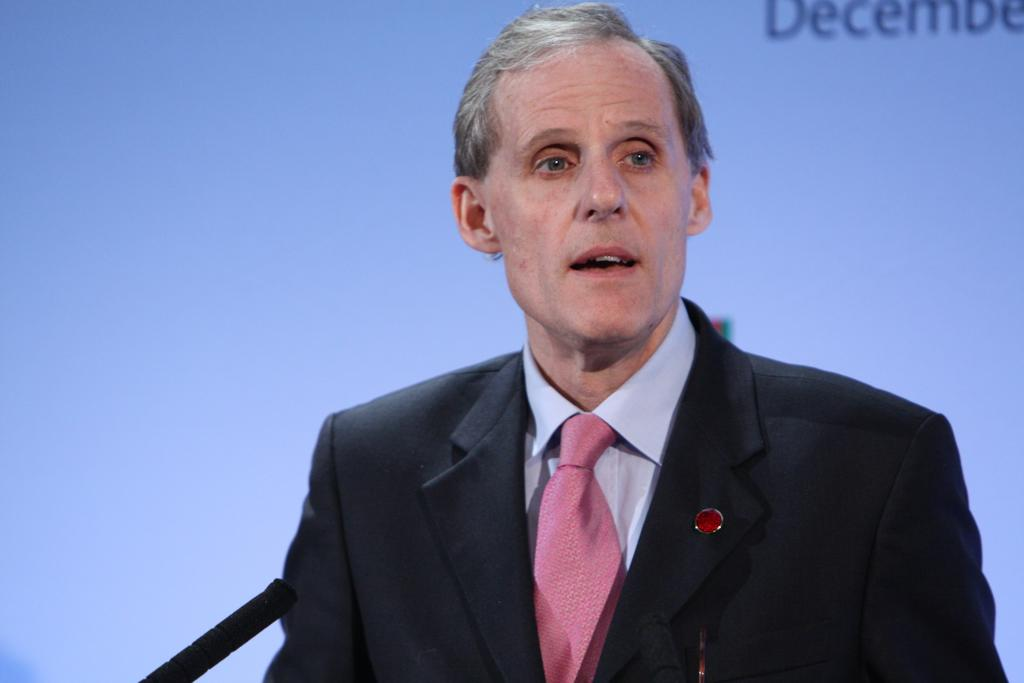Who is present in the image? There is a man in the image. What object can be seen in the man's hand? There is a mic in the image. What is visible in the background of the image? There is a screen in the background of the image. What type of apparel is the man wearing to protect himself from destruction in the image? There is no indication of destruction or protective apparel in the image; the man is simply holding a mic. 